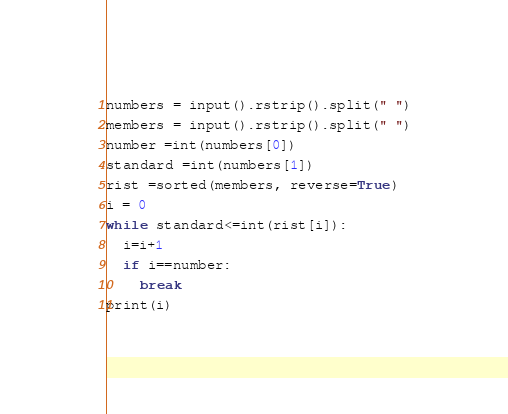<code> <loc_0><loc_0><loc_500><loc_500><_Python_>numbers = input().rstrip().split(" ")
members = input().rstrip().split(" ")
number =int(numbers[0])
standard =int(numbers[1])
rist =sorted(members, reverse=True)
i = 0
while standard<=int(rist[i]):
  i=i+1
  if i==number:
    break
print(i)</code> 